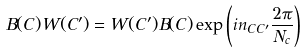<formula> <loc_0><loc_0><loc_500><loc_500>B ( C ) W ( C ^ { \prime } ) = W ( C ^ { \prime } ) B ( C ) \exp \left ( i n _ { C C ^ { \prime } } \frac { 2 \pi } { N _ { c } } \right )</formula> 